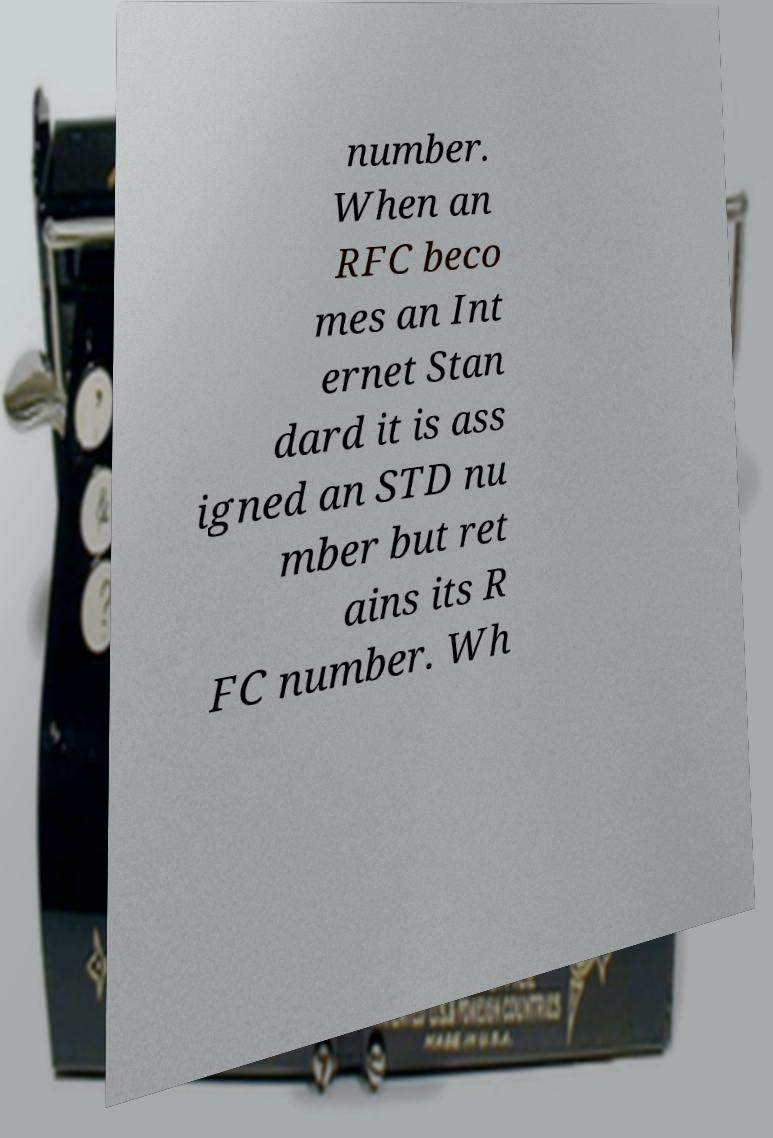Can you read and provide the text displayed in the image?This photo seems to have some interesting text. Can you extract and type it out for me? number. When an RFC beco mes an Int ernet Stan dard it is ass igned an STD nu mber but ret ains its R FC number. Wh 